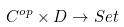Convert formula to latex. <formula><loc_0><loc_0><loc_500><loc_500>C ^ { o p } \times D \rightarrow S e t</formula> 